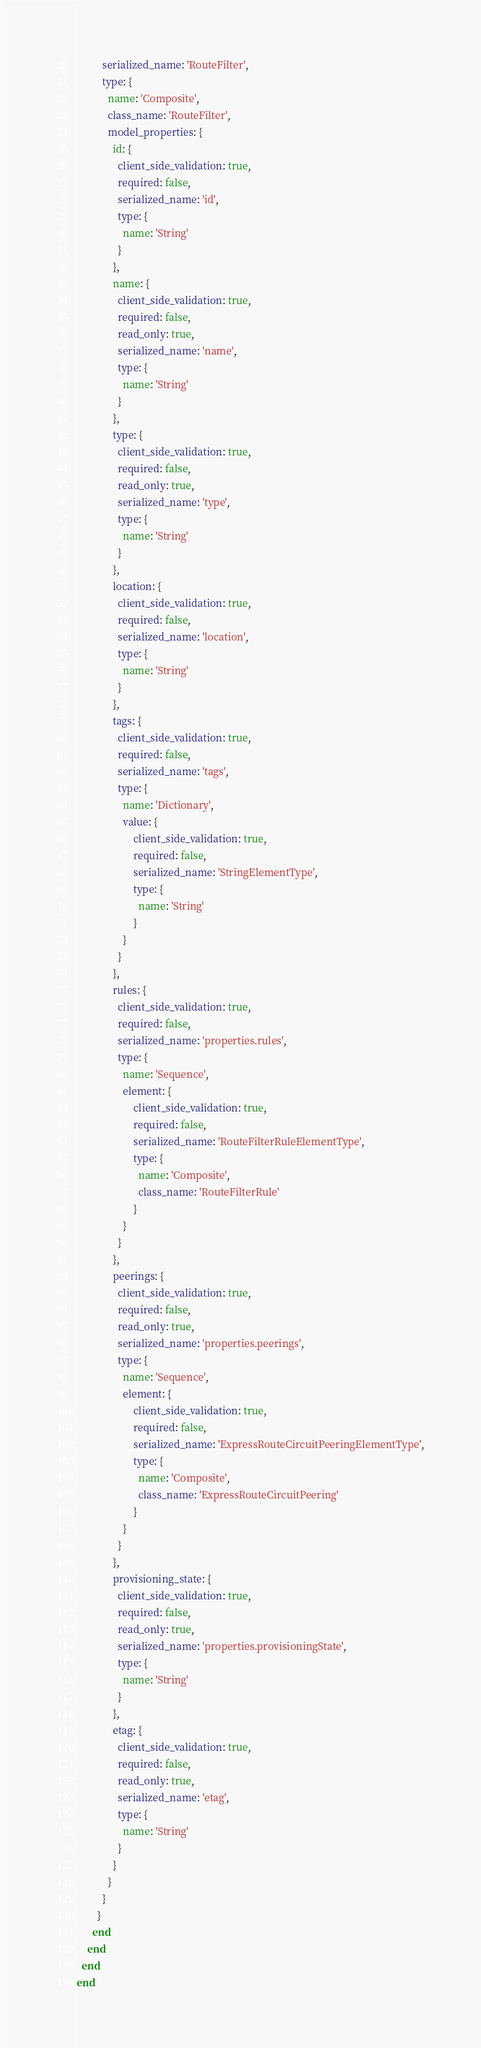<code> <loc_0><loc_0><loc_500><loc_500><_Ruby_>          serialized_name: 'RouteFilter',
          type: {
            name: 'Composite',
            class_name: 'RouteFilter',
            model_properties: {
              id: {
                client_side_validation: true,
                required: false,
                serialized_name: 'id',
                type: {
                  name: 'String'
                }
              },
              name: {
                client_side_validation: true,
                required: false,
                read_only: true,
                serialized_name: 'name',
                type: {
                  name: 'String'
                }
              },
              type: {
                client_side_validation: true,
                required: false,
                read_only: true,
                serialized_name: 'type',
                type: {
                  name: 'String'
                }
              },
              location: {
                client_side_validation: true,
                required: false,
                serialized_name: 'location',
                type: {
                  name: 'String'
                }
              },
              tags: {
                client_side_validation: true,
                required: false,
                serialized_name: 'tags',
                type: {
                  name: 'Dictionary',
                  value: {
                      client_side_validation: true,
                      required: false,
                      serialized_name: 'StringElementType',
                      type: {
                        name: 'String'
                      }
                  }
                }
              },
              rules: {
                client_side_validation: true,
                required: false,
                serialized_name: 'properties.rules',
                type: {
                  name: 'Sequence',
                  element: {
                      client_side_validation: true,
                      required: false,
                      serialized_name: 'RouteFilterRuleElementType',
                      type: {
                        name: 'Composite',
                        class_name: 'RouteFilterRule'
                      }
                  }
                }
              },
              peerings: {
                client_side_validation: true,
                required: false,
                read_only: true,
                serialized_name: 'properties.peerings',
                type: {
                  name: 'Sequence',
                  element: {
                      client_side_validation: true,
                      required: false,
                      serialized_name: 'ExpressRouteCircuitPeeringElementType',
                      type: {
                        name: 'Composite',
                        class_name: 'ExpressRouteCircuitPeering'
                      }
                  }
                }
              },
              provisioning_state: {
                client_side_validation: true,
                required: false,
                read_only: true,
                serialized_name: 'properties.provisioningState',
                type: {
                  name: 'String'
                }
              },
              etag: {
                client_side_validation: true,
                required: false,
                read_only: true,
                serialized_name: 'etag',
                type: {
                  name: 'String'
                }
              }
            }
          }
        }
      end
    end
  end
end
</code> 